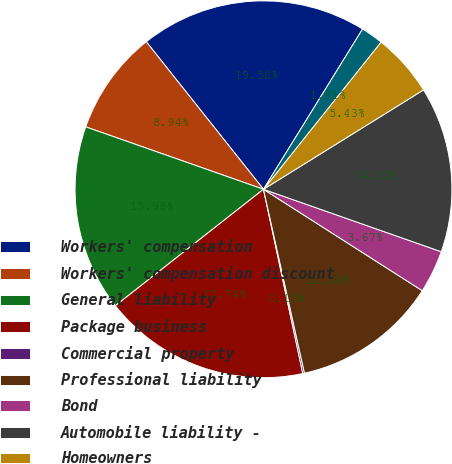Convert chart to OTSL. <chart><loc_0><loc_0><loc_500><loc_500><pie_chart><fcel>Workers' compensation<fcel>Workers' compensation discount<fcel>General liability<fcel>Package business<fcel>Commercial property<fcel>Professional liability<fcel>Bond<fcel>Automobile liability -<fcel>Homeowners<fcel>Catastrophes<nl><fcel>19.5%<fcel>8.94%<fcel>15.98%<fcel>17.74%<fcel>0.15%<fcel>12.46%<fcel>3.67%<fcel>14.22%<fcel>5.43%<fcel>1.91%<nl></chart> 